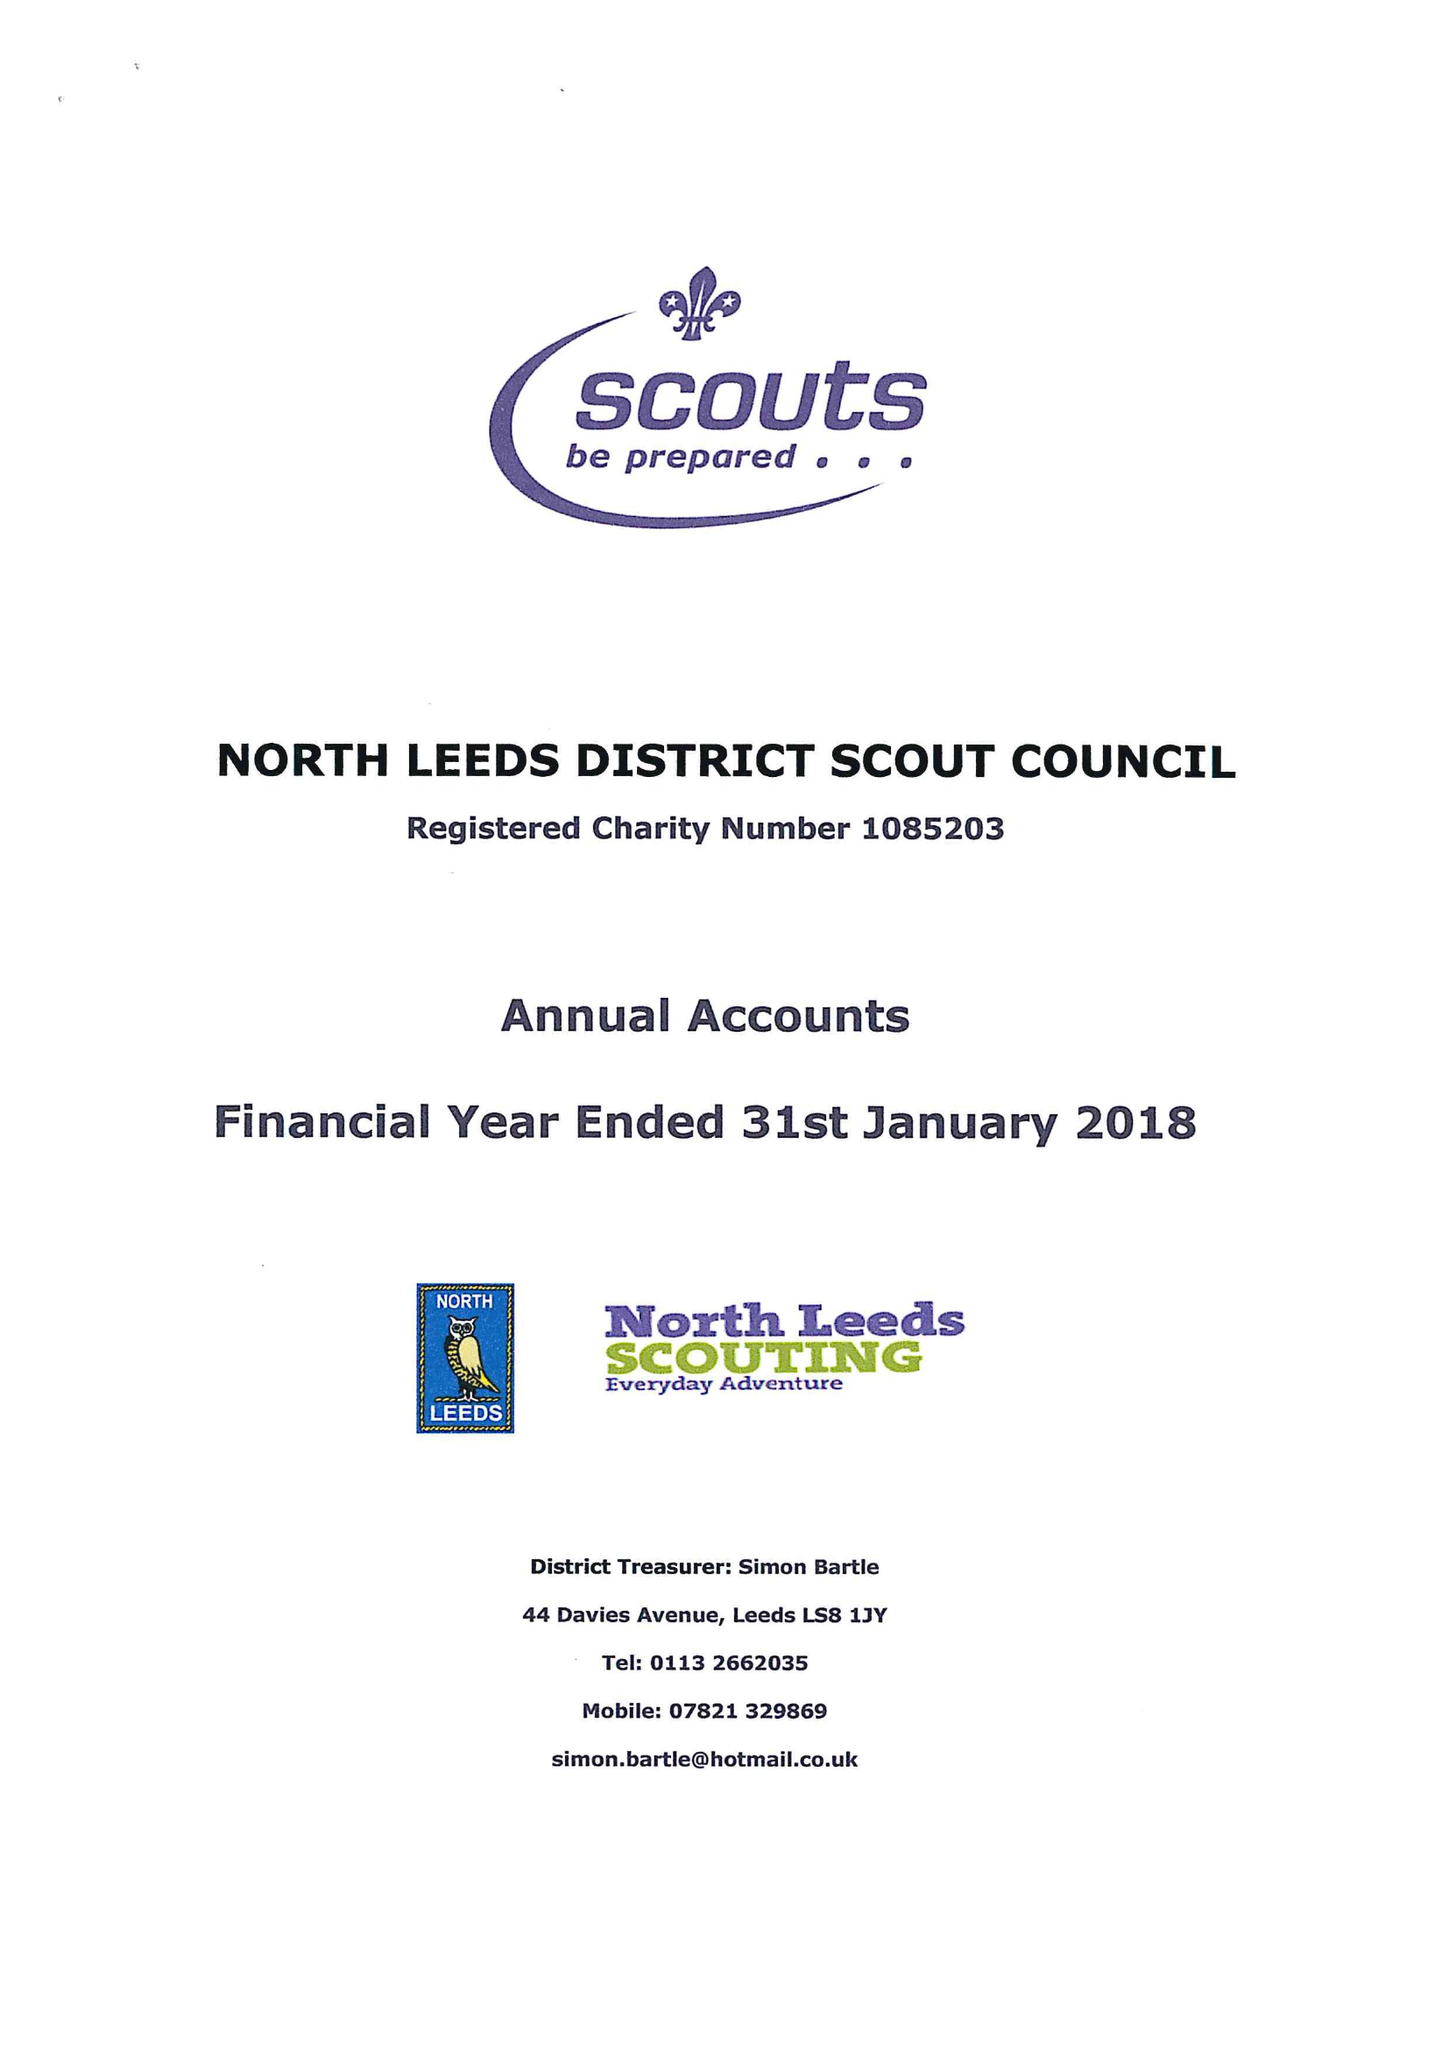What is the value for the charity_name?
Answer the question using a single word or phrase. North Leeds District Scout Council 